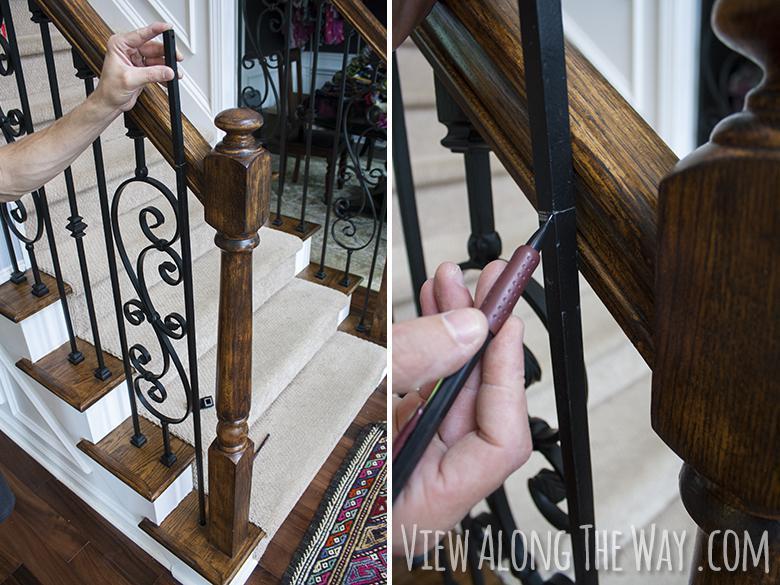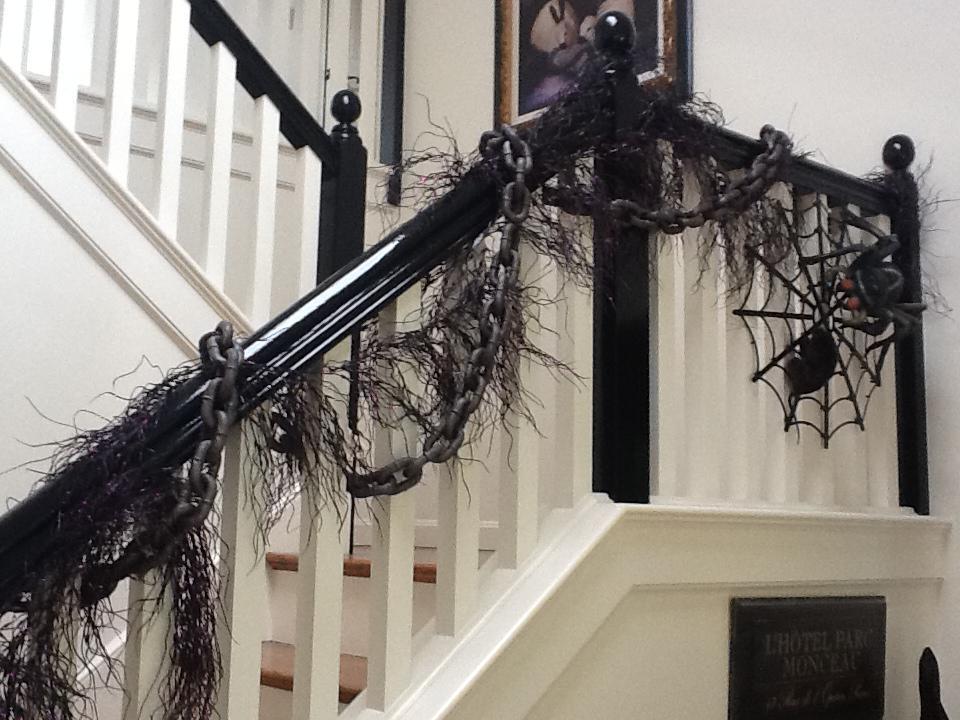The first image is the image on the left, the second image is the image on the right. For the images displayed, is the sentence "The left image shows a staircase with an ornate black wrought iron rail and a corner post featuring wrought iron curved around to form a cylinder shape." factually correct? Answer yes or no. No. The first image is the image on the left, the second image is the image on the right. Given the left and right images, does the statement "In at least one image there is a staircase with brown and white steps with metal rods with curled and s shapes." hold true? Answer yes or no. Yes. 